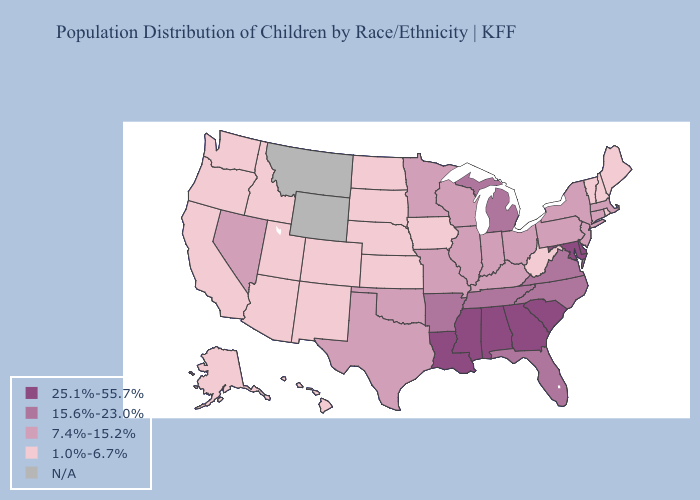Does New Jersey have the lowest value in the Northeast?
Answer briefly. No. Does Utah have the lowest value in the West?
Short answer required. Yes. What is the value of Montana?
Answer briefly. N/A. Among the states that border Michigan , which have the highest value?
Give a very brief answer. Indiana, Ohio, Wisconsin. Does Ohio have the lowest value in the USA?
Concise answer only. No. What is the value of Indiana?
Quick response, please. 7.4%-15.2%. Name the states that have a value in the range N/A?
Keep it brief. Montana, Wyoming. What is the value of West Virginia?
Concise answer only. 1.0%-6.7%. What is the lowest value in states that border Wyoming?
Write a very short answer. 1.0%-6.7%. What is the lowest value in the South?
Short answer required. 1.0%-6.7%. Among the states that border South Dakota , does Nebraska have the lowest value?
Give a very brief answer. Yes. What is the lowest value in states that border Nebraska?
Quick response, please. 1.0%-6.7%. Does Delaware have the highest value in the USA?
Answer briefly. Yes. 